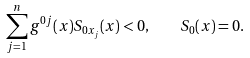<formula> <loc_0><loc_0><loc_500><loc_500>\sum _ { j = 1 } ^ { n } g ^ { 0 j } ( x ) S _ { 0 x _ { j } } ( x ) < 0 , \quad S _ { 0 } ( x ) = 0 .</formula> 